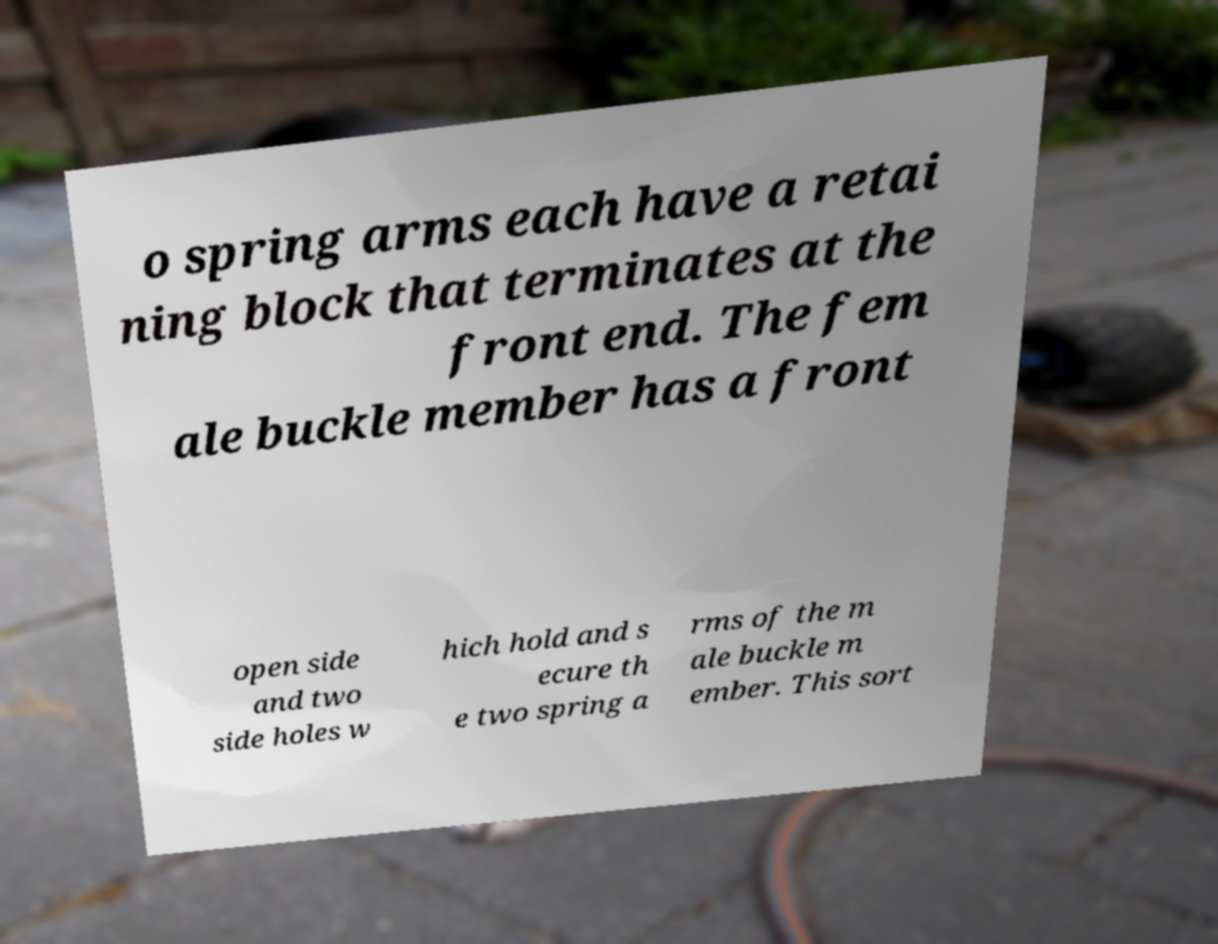Could you extract and type out the text from this image? o spring arms each have a retai ning block that terminates at the front end. The fem ale buckle member has a front open side and two side holes w hich hold and s ecure th e two spring a rms of the m ale buckle m ember. This sort 